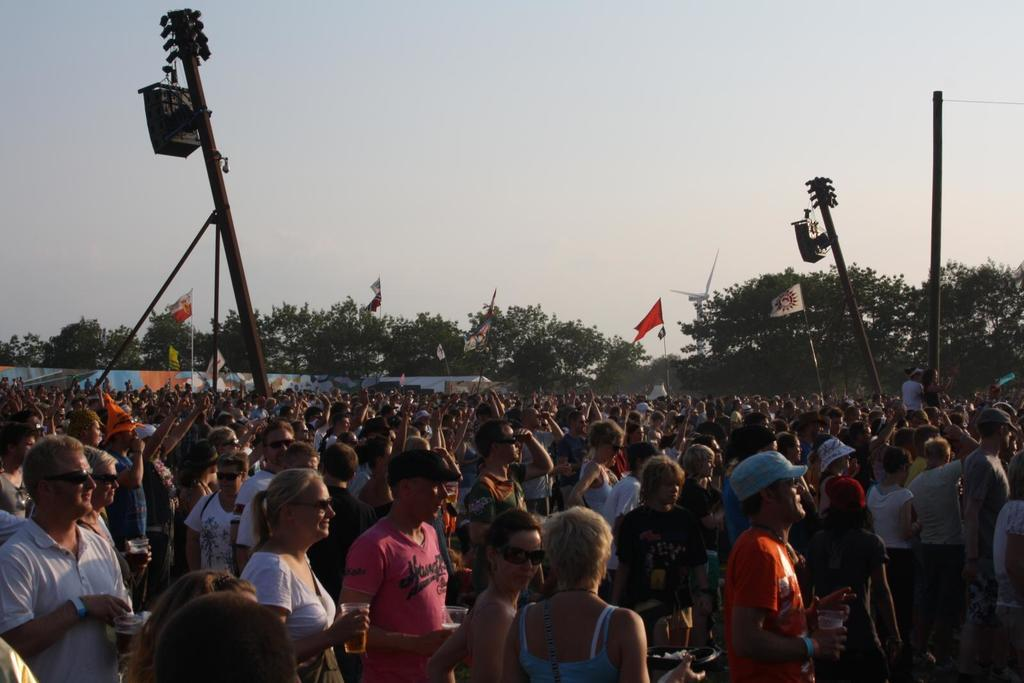How many people are in the image? There is a group of people in the image, but the exact number is not specified. What can be seen in the image besides the people? There are poles, flags, trees, and unspecified objects in the image. What is the purpose of the poles in the image? The purpose of the poles is not specified, but they may be used for supporting flags or other objects. What is visible in the background of the image? The sky is visible in the background of the image. What type of sponge is being used to clean the faucet in the image? There is no sponge or faucet present in the image. How many volleyballs are visible in the image? There is no mention of volleyballs in the image. 